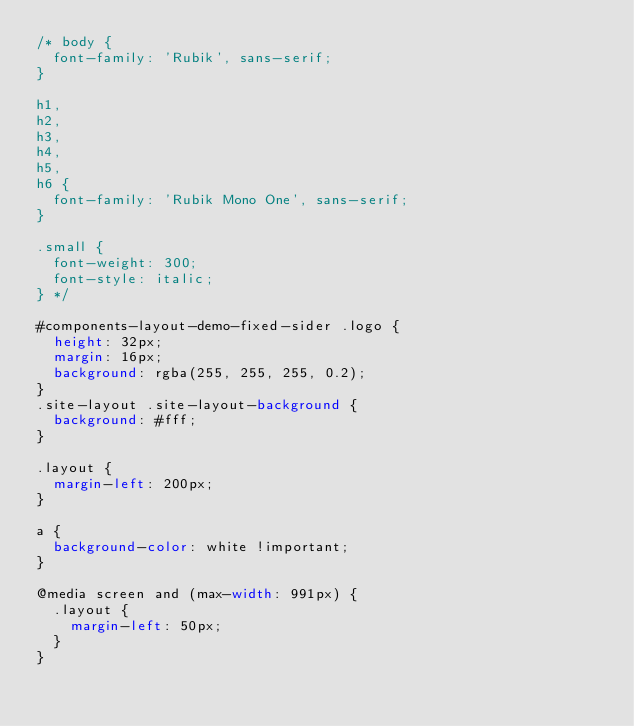Convert code to text. <code><loc_0><loc_0><loc_500><loc_500><_CSS_>/* body {
  font-family: 'Rubik', sans-serif;
}

h1,
h2,
h3,
h4,
h5,
h6 {
  font-family: 'Rubik Mono One', sans-serif;
}

.small {
  font-weight: 300;
  font-style: italic;
} */

#components-layout-demo-fixed-sider .logo {
  height: 32px;
  margin: 16px;
  background: rgba(255, 255, 255, 0.2);
}
.site-layout .site-layout-background {
  background: #fff;
}

.layout {
  margin-left: 200px;
}

a {
  background-color: white !important;
}

@media screen and (max-width: 991px) {
  .layout {
    margin-left: 50px;
  }
}
</code> 